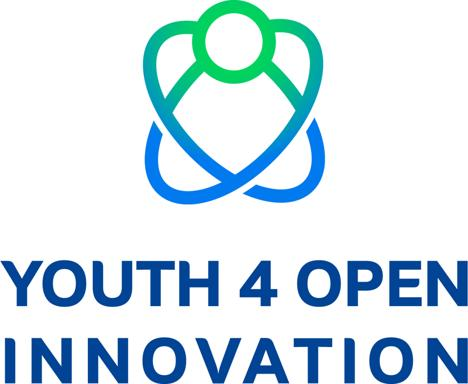Can you describe the design of the logo? The logo features a blue and green color scheme and has a stylized figure of a person incorporated into its design. The overall presentation is vibrant, energetic, and youthful, which aligns with the theme of "Youth 4 Open Innovation." 